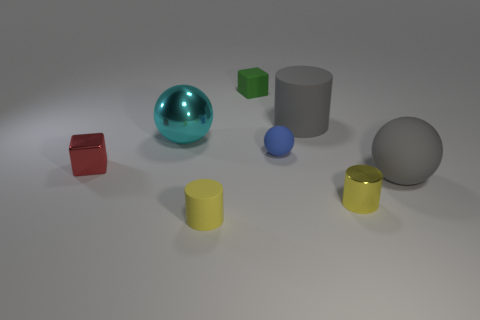There is a cylinder that is behind the gray sphere; is its color the same as the tiny metallic thing that is behind the large gray rubber ball?
Provide a succinct answer. No. What is the size of the shiny object that is the same color as the small rubber cylinder?
Provide a succinct answer. Small. How many other objects are the same size as the blue matte ball?
Offer a very short reply. 4. What is the color of the small cylinder that is on the right side of the large gray matte cylinder?
Give a very brief answer. Yellow. Is the material of the small object to the left of the small yellow matte object the same as the gray cylinder?
Provide a succinct answer. No. How many cylinders are both in front of the yellow metal cylinder and behind the tiny metal cylinder?
Your answer should be very brief. 0. There is a large matte thing in front of the tiny metal thing to the left of the small yellow thing that is in front of the tiny yellow metallic thing; what color is it?
Your answer should be compact. Gray. What number of other things are there of the same shape as the big metallic object?
Your response must be concise. 2. Is there a big cyan metal object that is right of the tiny yellow cylinder on the right side of the rubber cube?
Offer a terse response. No. What number of matte objects are either tiny spheres or gray objects?
Offer a very short reply. 3. 